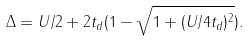Convert formula to latex. <formula><loc_0><loc_0><loc_500><loc_500>\Delta = U / 2 + 2 t _ { d } ( 1 - \sqrt { 1 + ( U / 4 t _ { d } ) ^ { 2 } } ) .</formula> 